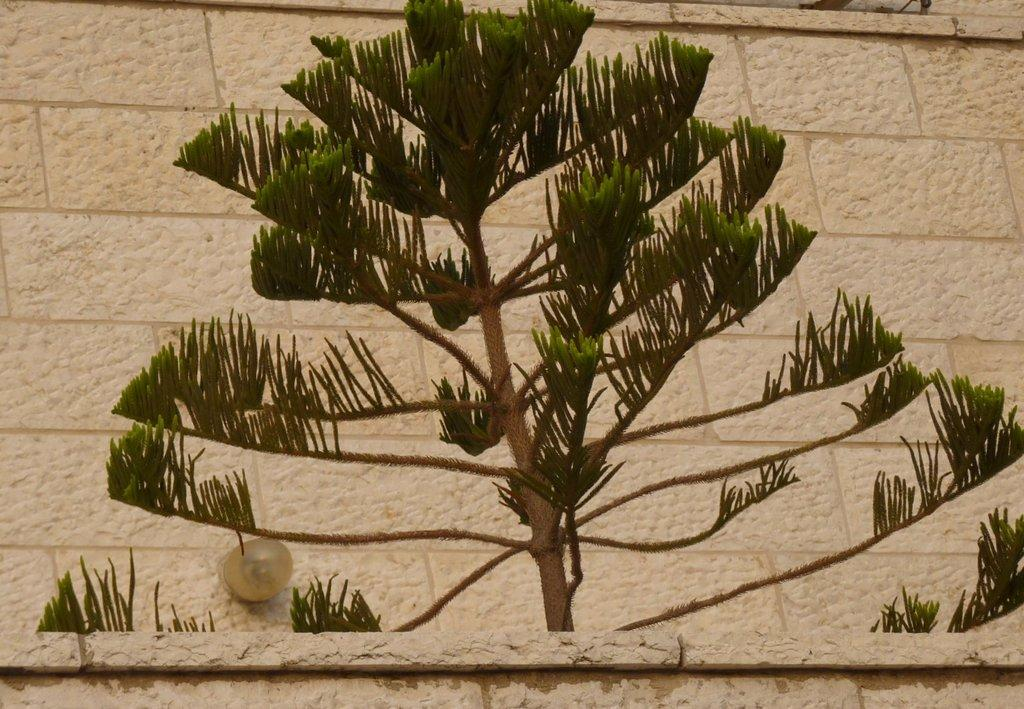What is present in the image? There is a plant in the image. What can be seen in the background of the image? There is a wall in the background of the image. Can you describe the wall in the background? There is a light attached to the wall in the background. What type of powder is being used to create the plant in the image? There is no powder present in the image, and the plant is a living organism, not a creation made from powder. 